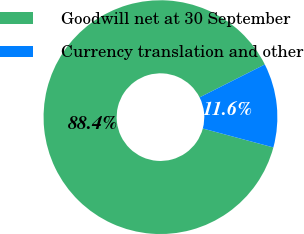Convert chart to OTSL. <chart><loc_0><loc_0><loc_500><loc_500><pie_chart><fcel>Goodwill net at 30 September<fcel>Currency translation and other<nl><fcel>88.39%<fcel>11.61%<nl></chart> 